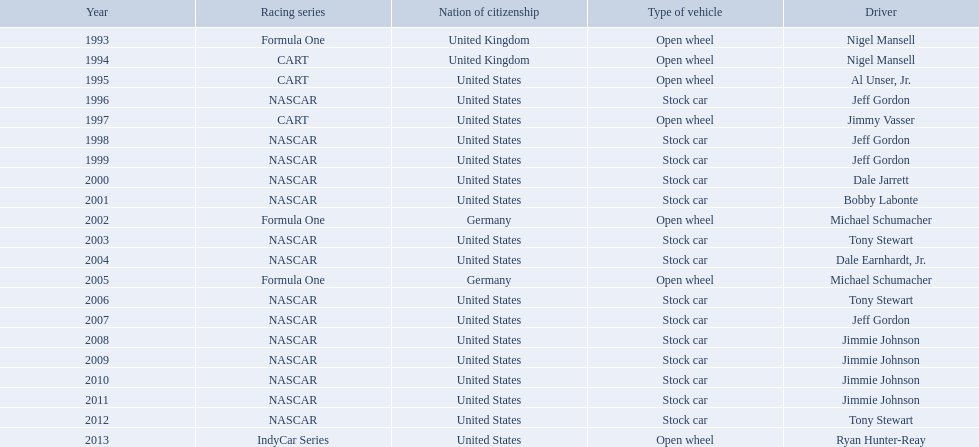Who won an espy in the year 2004, bobby labonte, tony stewart, dale earnhardt jr., or jeff gordon? Dale Earnhardt, Jr. Who won the espy in the year 1997; nigel mansell, al unser, jr., jeff gordon, or jimmy vasser? Jimmy Vasser. Which one only has one espy; nigel mansell, al unser jr., michael schumacher, or jeff gordon? Al Unser, Jr. 